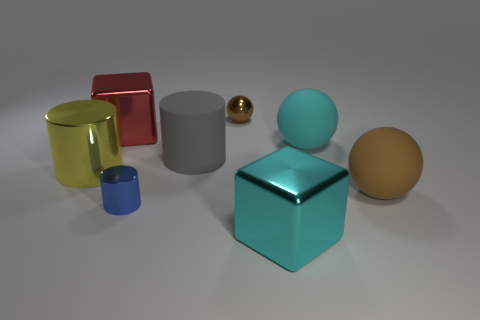What can you infer about the texture of the objects? The objects appear to have smooth and reflective surfaces, suggesting they could be made of materials like polished metal or plastic. The lack of any visible texture details implies they are quite sleek. 